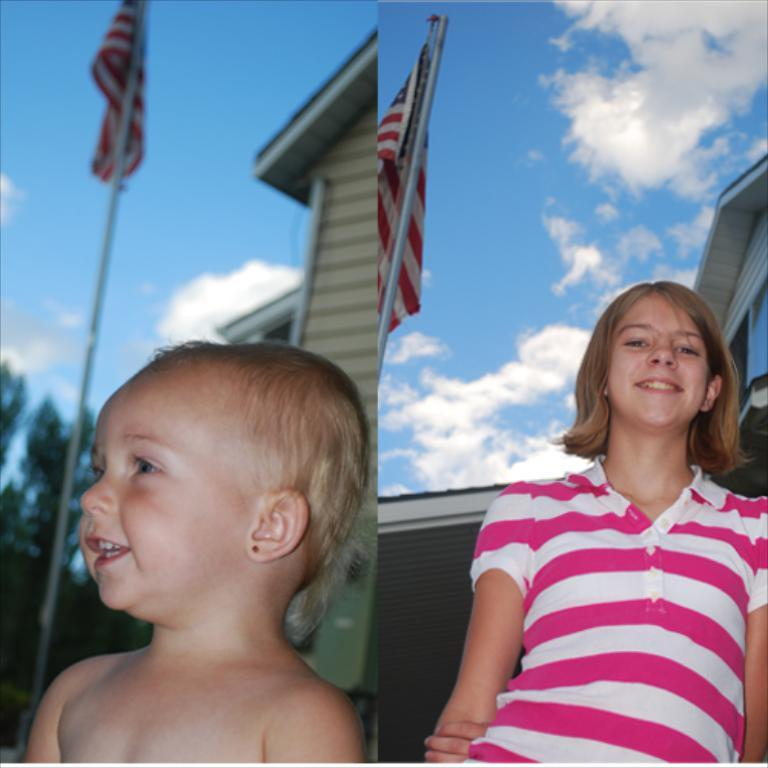What type of artwork is the image? The image is a collage. Can you describe the people in the image? There is a child and a girl smiling in the image. What symbols are present in the image? There are flags and buildings in the image. What natural elements can be seen in the image? There are trees in the image. What is visible in the background of the image? The sky with clouds is visible in the background of the image. What time is displayed on the clock in the image? There is no clock present in the image. What type of writing instrument is the girl using in the image? The girl is not using a quill or any writing instrument in the image; she is simply smiling. 